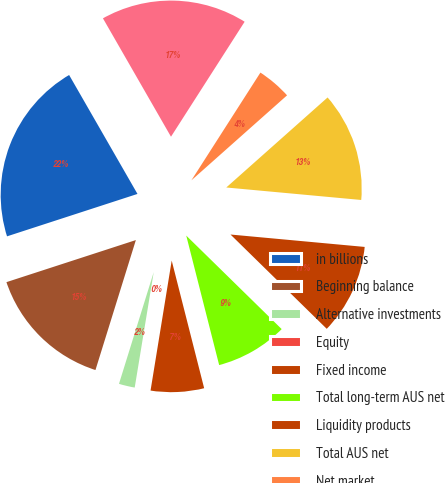Convert chart to OTSL. <chart><loc_0><loc_0><loc_500><loc_500><pie_chart><fcel>in billions<fcel>Beginning balance<fcel>Alternative investments<fcel>Equity<fcel>Fixed income<fcel>Total long-term AUS net<fcel>Liquidity products<fcel>Total AUS net<fcel>Net market<fcel>Ending balance<nl><fcel>21.7%<fcel>15.2%<fcel>2.2%<fcel>0.03%<fcel>6.53%<fcel>8.7%<fcel>10.87%<fcel>13.03%<fcel>4.37%<fcel>17.37%<nl></chart> 